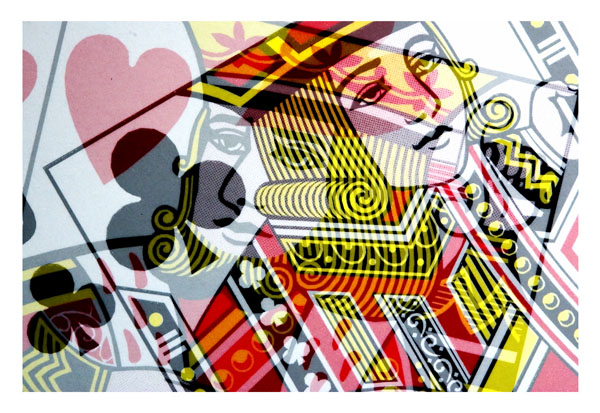Can you tell me what colors are predominantly used in the playing card design? The playing card design predominantly features bold colors such as red, yellow, and black with accents of white. These colors create a striking contrast that highlights the intricate details and patterns on the card. 